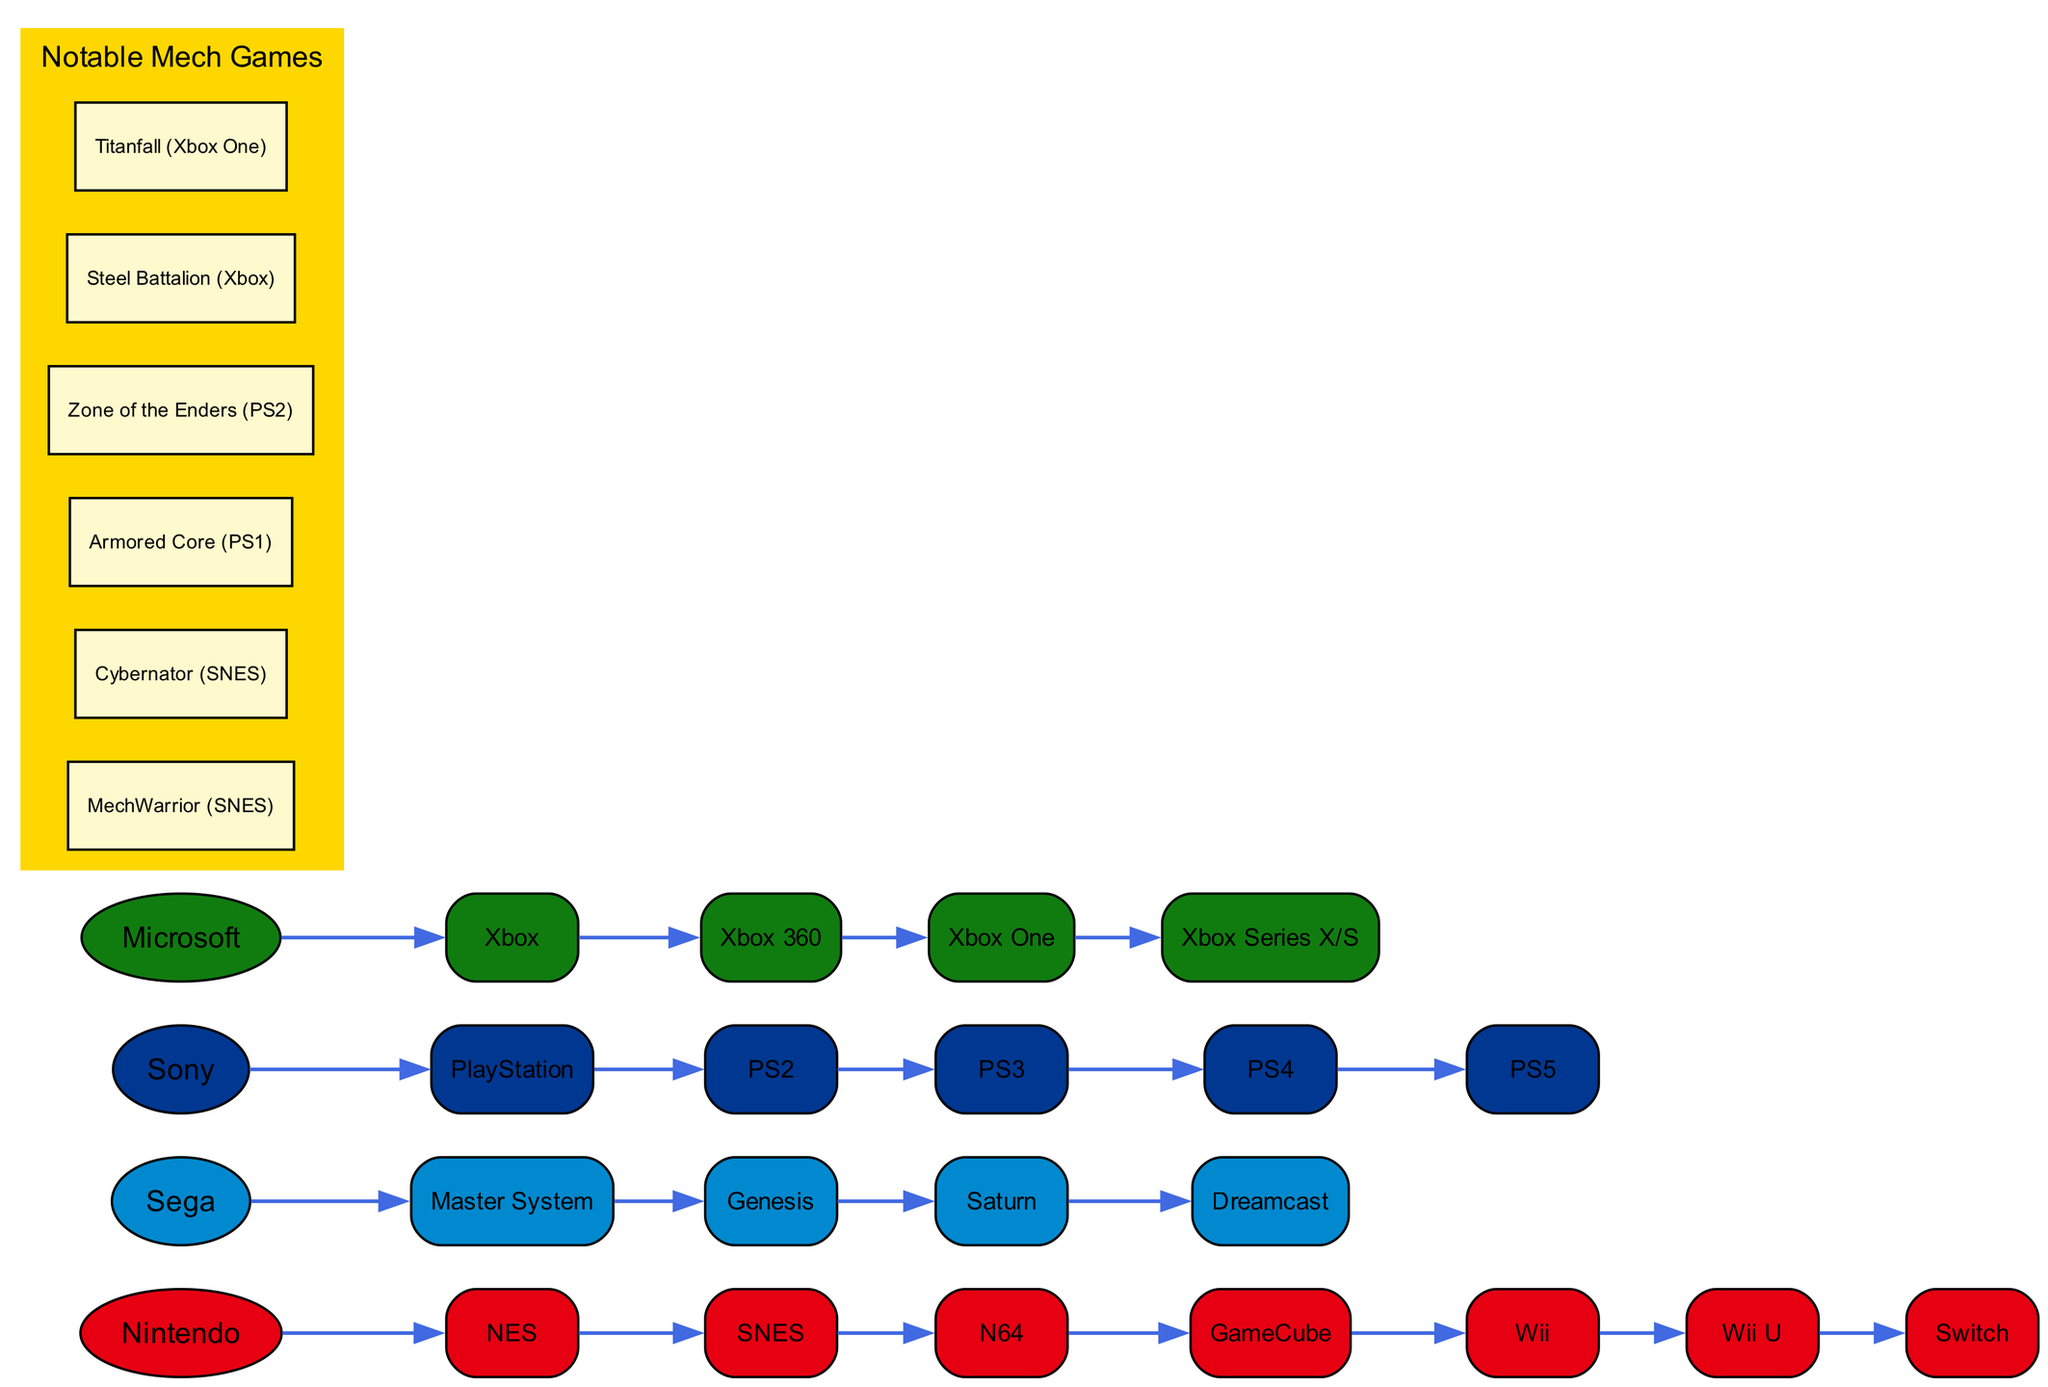What is the first console in the Nintendo lineage? The first console shown under the Nintendo lineage is the NES. It is the first node under the Nintendo node in the diagram.
Answer: NES How many consoles are in the Sega lineage? The Sega lineage includes five consoles: Master System, Genesis, Saturn, and Dreamcast, as shown directly under the Sega node.
Answer: 5 Which company has the most recent console in the diagram? The most recent console is the PS5, which is listed under the Sony node. It is the last console shown in a sequential manner after PS4, PS3, and PS2.
Answer: Sony What was the successor of the Xbox 360? The direct successor of the Xbox 360, as indicated in the diagram, is the Xbox One, which is listed right under the Xbox 360 node.
Answer: Xbox One Which console comes after the N64? The console that directly follows the N64 in the lineage is the GameCube. This can be determined by tracing the path from Nintendo to NES, then to SNES, then N64, and finally to GameCube.
Answer: GameCube Which company has a console named after a color? The company Microsoft has a console named Xbox Series X/S, which includes 'Series X/S' that indicates a color (green). This is confirmed by looking at the last node in the Microsoft section of the diagram.
Answer: Microsoft How many notable mech games are listed in the diagram? There are six notable mech games listed, such as MechWarrior, Cybernator, etc. This can be counted from the section specifically designated for notable mech games within the diagram.
Answer: 6 Which console did the Dreamcast succeed? The Dreamcast succeeded the Saturn based on the lineage flow under the Sega company node in the diagram.
Answer: Saturn What color represents the Sony consoles in the diagram? The Sony consoles are represented by the color #003791, which is specified as the color for nodes under the Sony section of the diagram.
Answer: #003791 